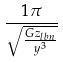Convert formula to latex. <formula><loc_0><loc_0><loc_500><loc_500>\frac { 1 \pi } { \sqrt { \frac { G z _ { l b n } } { y ^ { 3 } } } }</formula> 